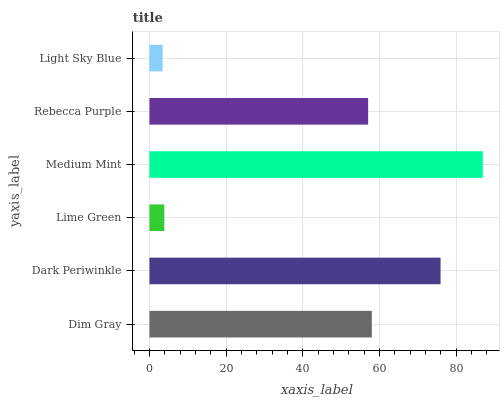Is Light Sky Blue the minimum?
Answer yes or no. Yes. Is Medium Mint the maximum?
Answer yes or no. Yes. Is Dark Periwinkle the minimum?
Answer yes or no. No. Is Dark Periwinkle the maximum?
Answer yes or no. No. Is Dark Periwinkle greater than Dim Gray?
Answer yes or no. Yes. Is Dim Gray less than Dark Periwinkle?
Answer yes or no. Yes. Is Dim Gray greater than Dark Periwinkle?
Answer yes or no. No. Is Dark Periwinkle less than Dim Gray?
Answer yes or no. No. Is Dim Gray the high median?
Answer yes or no. Yes. Is Rebecca Purple the low median?
Answer yes or no. Yes. Is Dark Periwinkle the high median?
Answer yes or no. No. Is Dim Gray the low median?
Answer yes or no. No. 